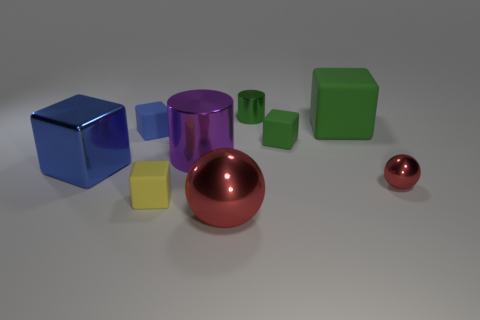There is another big thing that is the same shape as the blue shiny thing; what is its color?
Provide a short and direct response. Green. The cylinder that is the same size as the yellow cube is what color?
Offer a very short reply. Green. There is a tiny yellow thing; does it have the same shape as the small green object in front of the tiny cylinder?
Provide a succinct answer. Yes. What shape is the small thing that is the same color as the small cylinder?
Offer a terse response. Cube. How many small objects are to the left of the metallic object that is in front of the rubber cube that is in front of the purple object?
Provide a short and direct response. 2. How big is the blue thing that is behind the big blue thing in front of the tiny green metal thing?
Your answer should be compact. Small. There is a blue object that is made of the same material as the tiny yellow cube; what is its size?
Offer a terse response. Small. There is a small matte thing that is on the left side of the small green cube and behind the big blue metal block; what is its shape?
Provide a succinct answer. Cube. Are there the same number of green matte objects that are behind the small cylinder and blue matte blocks?
Your answer should be very brief. No. How many things are large blue rubber cylinders or cubes that are behind the big blue cube?
Ensure brevity in your answer.  3. 